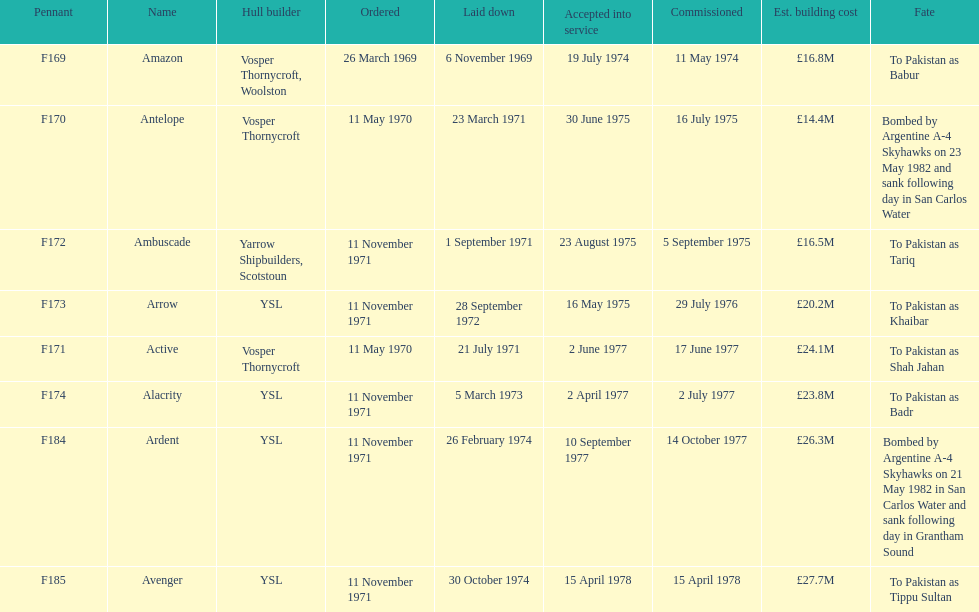Would you mind parsing the complete table? {'header': ['Pennant', 'Name', 'Hull builder', 'Ordered', 'Laid down', 'Accepted into service', 'Commissioned', 'Est. building cost', 'Fate'], 'rows': [['F169', 'Amazon', 'Vosper Thornycroft, Woolston', '26 March 1969', '6 November 1969', '19 July 1974', '11 May 1974', '£16.8M', 'To Pakistan as Babur'], ['F170', 'Antelope', 'Vosper Thornycroft', '11 May 1970', '23 March 1971', '30 June 1975', '16 July 1975', '£14.4M', 'Bombed by Argentine A-4 Skyhawks on 23 May 1982 and sank following day in San Carlos Water'], ['F172', 'Ambuscade', 'Yarrow Shipbuilders, Scotstoun', '11 November 1971', '1 September 1971', '23 August 1975', '5 September 1975', '£16.5M', 'To Pakistan as Tariq'], ['F173', 'Arrow', 'YSL', '11 November 1971', '28 September 1972', '16 May 1975', '29 July 1976', '£20.2M', 'To Pakistan as Khaibar'], ['F171', 'Active', 'Vosper Thornycroft', '11 May 1970', '21 July 1971', '2 June 1977', '17 June 1977', '£24.1M', 'To Pakistan as Shah Jahan'], ['F174', 'Alacrity', 'YSL', '11 November 1971', '5 March 1973', '2 April 1977', '2 July 1977', '£23.8M', 'To Pakistan as Badr'], ['F184', 'Ardent', 'YSL', '11 November 1971', '26 February 1974', '10 September 1977', '14 October 1977', '£26.3M', 'Bombed by Argentine A-4 Skyhawks on 21 May 1982 in San Carlos Water and sank following day in Grantham Sound'], ['F185', 'Avenger', 'YSL', '11 November 1971', '30 October 1974', '15 April 1978', '15 April 1978', '£27.7M', 'To Pakistan as Tippu Sultan']]} What is the subsequent pennant following f172? F173. 